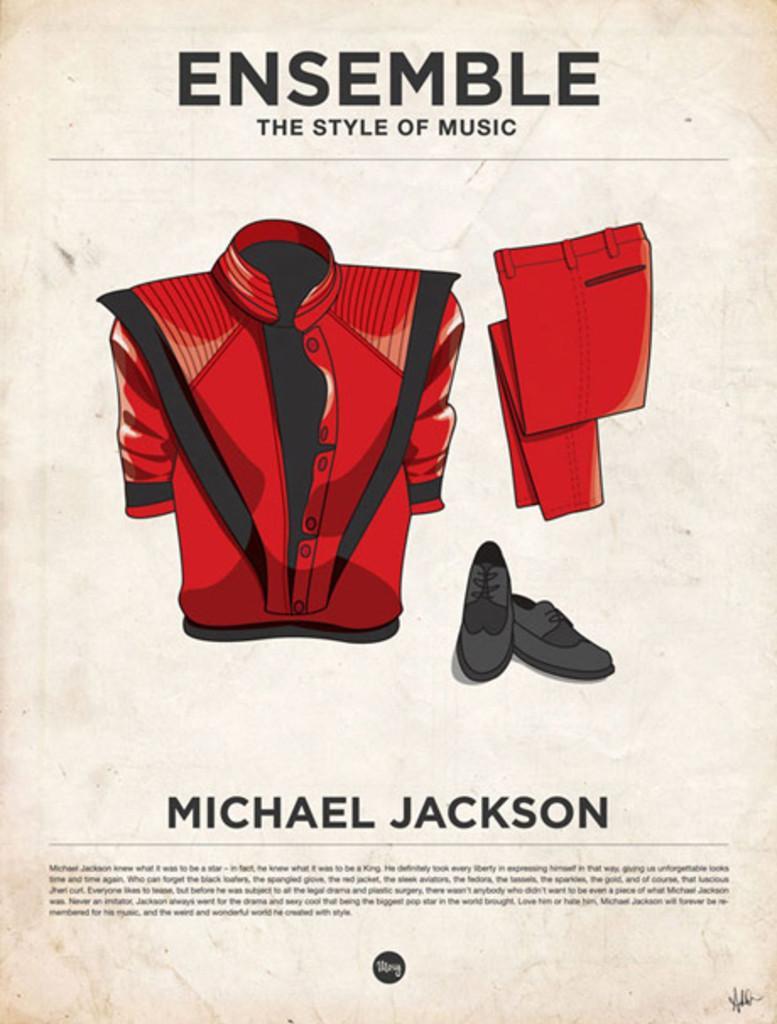Please provide a concise description of this image. In this image we can see a poster. We can see few clothing and some text on the poster. 